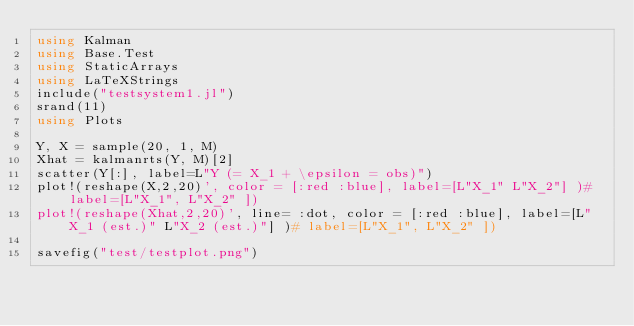Convert code to text. <code><loc_0><loc_0><loc_500><loc_500><_Julia_>using Kalman
using Base.Test
using StaticArrays
using LaTeXStrings
include("testsystem1.jl")
srand(11)
using Plots

Y, X = sample(20, 1, M)
Xhat = kalmanrts(Y, M)[2]
scatter(Y[:], label=L"Y (= X_1 + \epsilon = obs)")
plot!(reshape(X,2,20)', color = [:red :blue], label=[L"X_1" L"X_2"] )# label=[L"X_1", L"X_2" ])
plot!(reshape(Xhat,2,20)', line= :dot, color = [:red :blue], label=[L"X_1 (est.)" L"X_2 (est.)"] )# label=[L"X_1", L"X_2" ])

savefig("test/testplot.png")</code> 